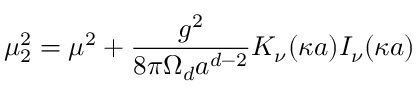<formula> <loc_0><loc_0><loc_500><loc_500>\mu _ { 2 } ^ { 2 } = \mu ^ { 2 } + { \frac { g ^ { 2 } } { 8 { \pi } \Omega _ { d } a ^ { d - 2 } } } K _ { \nu } ( \kappa a ) I _ { \nu } ( \kappa a )</formula> 